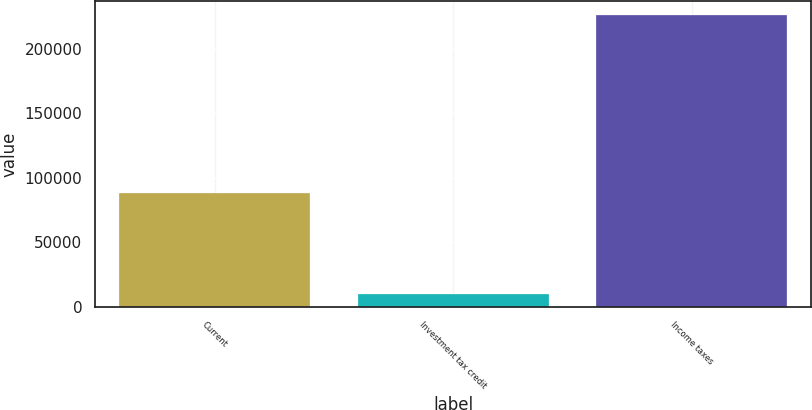Convert chart to OTSL. <chart><loc_0><loc_0><loc_500><loc_500><bar_chart><fcel>Current<fcel>Investment tax credit<fcel>Income taxes<nl><fcel>88291<fcel>9930<fcel>225981<nl></chart> 